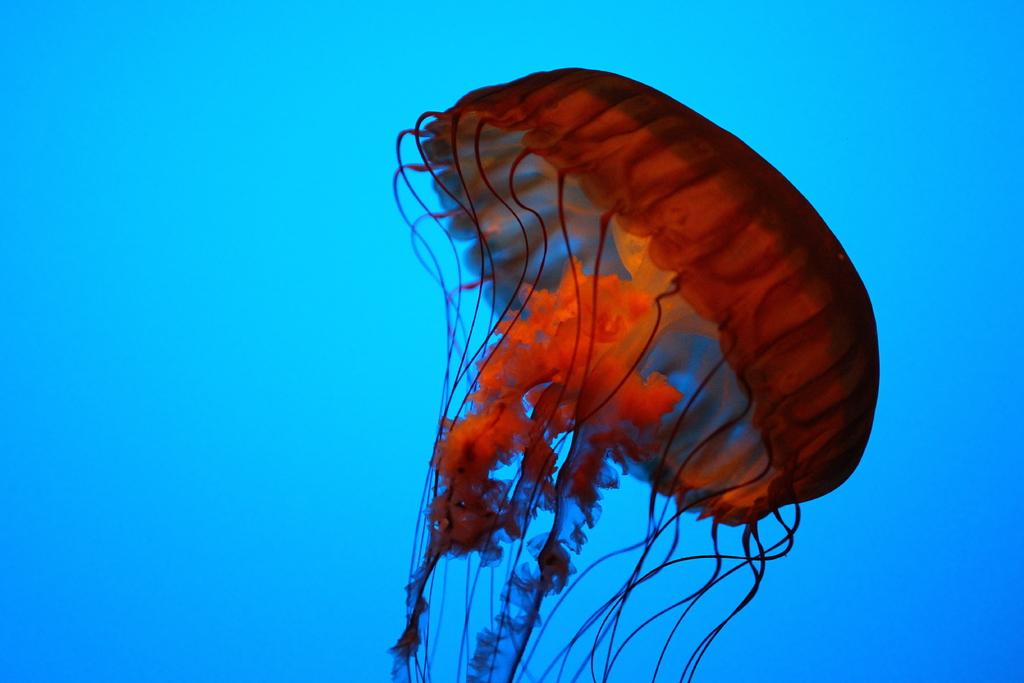Where was the picture taken? The picture was taken in the water. What can be seen in the center of the image? There is a jellyfish in the center of the image. What type of stamp can be seen on the jellyfish in the image? There is no stamp present on the jellyfish in the image. What role does the brain play in the image? There is no brain present in the image; it features a jellyfish in the water. 